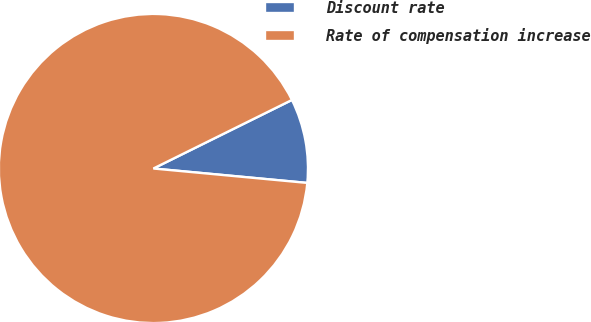Convert chart. <chart><loc_0><loc_0><loc_500><loc_500><pie_chart><fcel>Discount rate<fcel>Rate of compensation increase<nl><fcel>8.8%<fcel>91.2%<nl></chart> 